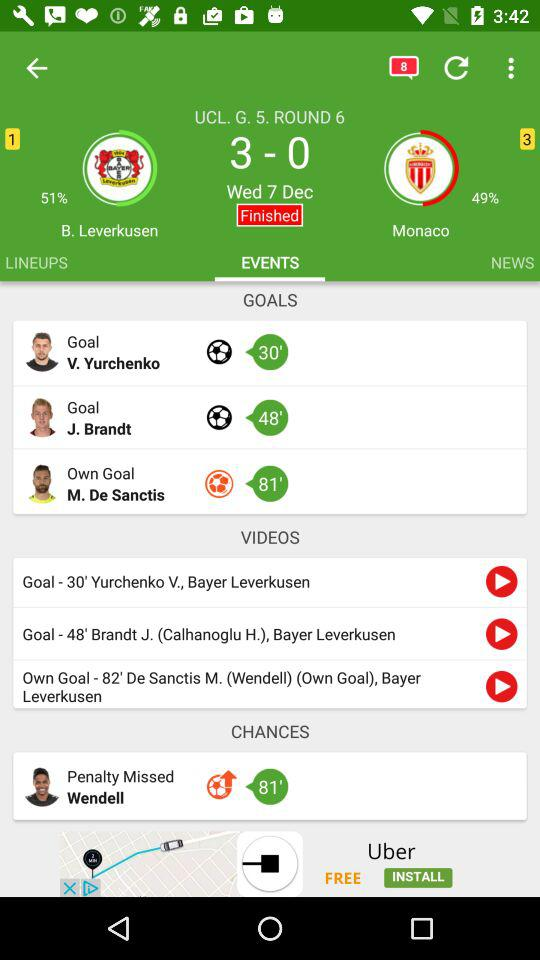How many games has "Monaco" lost?
When the provided information is insufficient, respond with <no answer>. <no answer> 